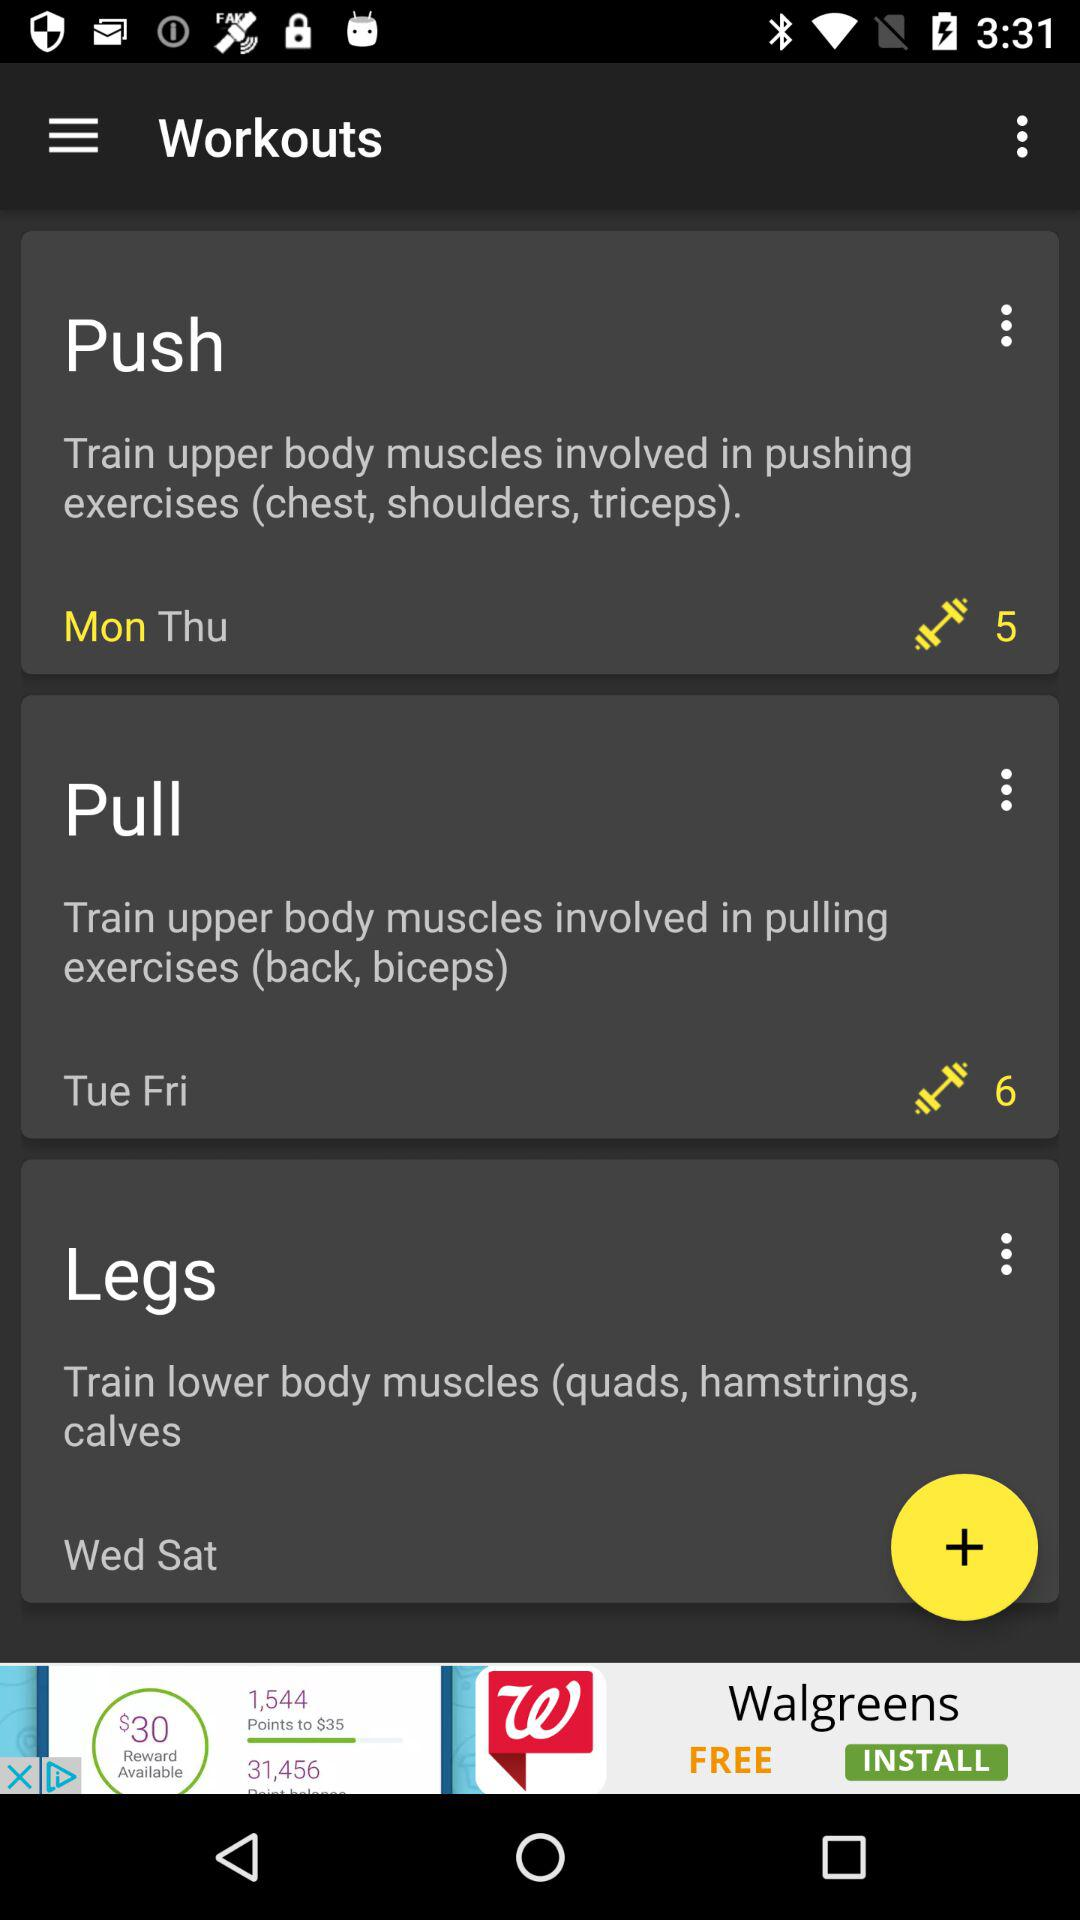Which days are for leg's workout? The days for leg's workout are Wednesday and Saturday. 